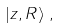<formula> <loc_0><loc_0><loc_500><loc_500>\left | z , R \right \rangle \, ,</formula> 